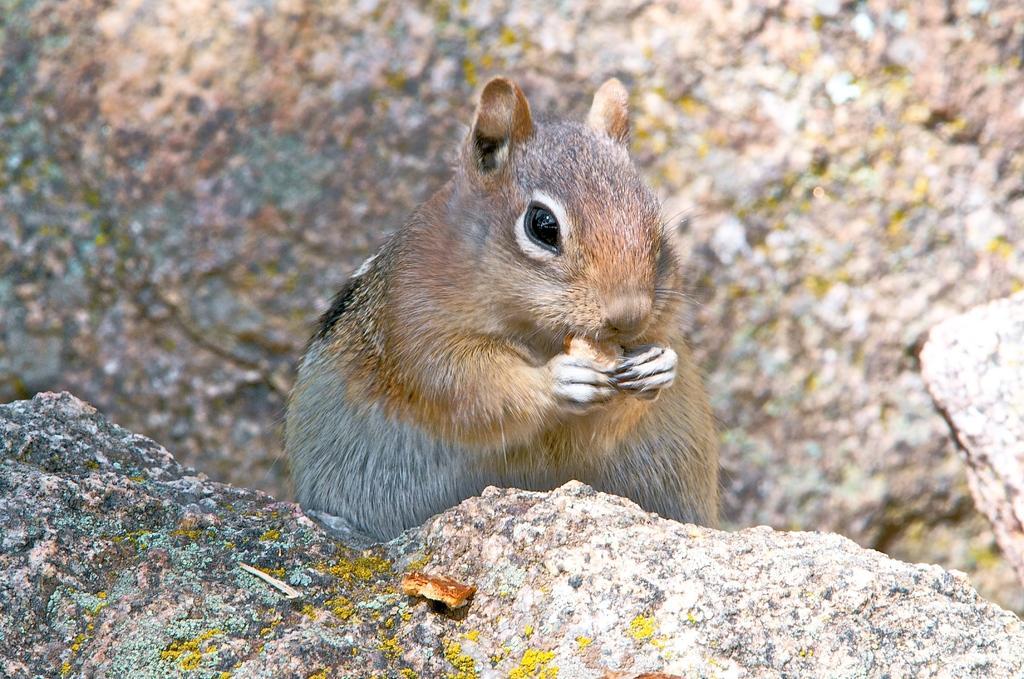In one or two sentences, can you explain what this image depicts? In the center of the image there is a squirrel. At the bottom there is a rock. 